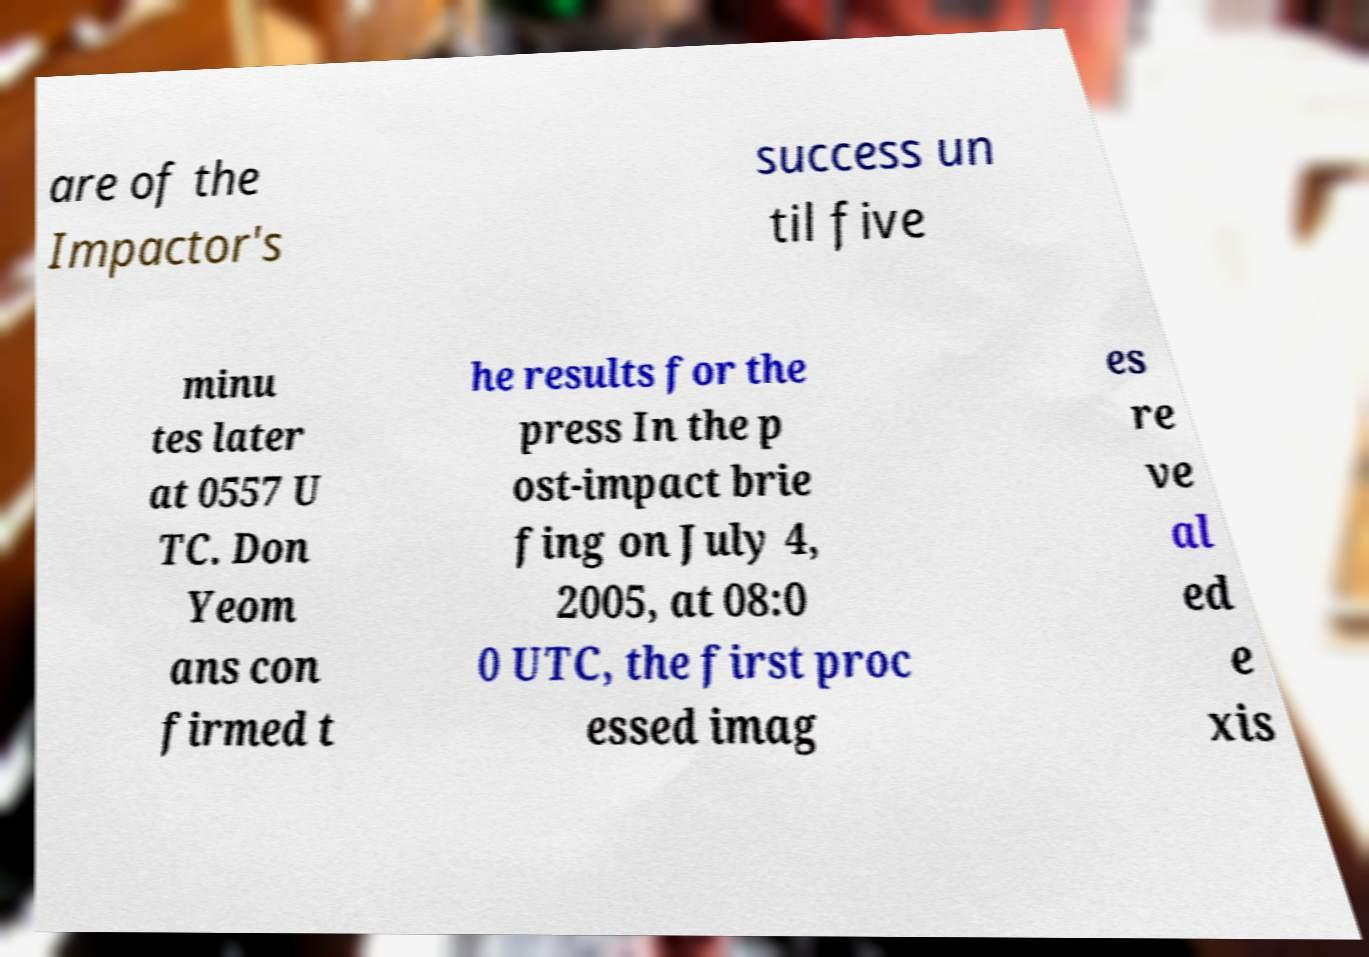Could you assist in decoding the text presented in this image and type it out clearly? are of the Impactor's success un til five minu tes later at 0557 U TC. Don Yeom ans con firmed t he results for the press In the p ost-impact brie fing on July 4, 2005, at 08:0 0 UTC, the first proc essed imag es re ve al ed e xis 